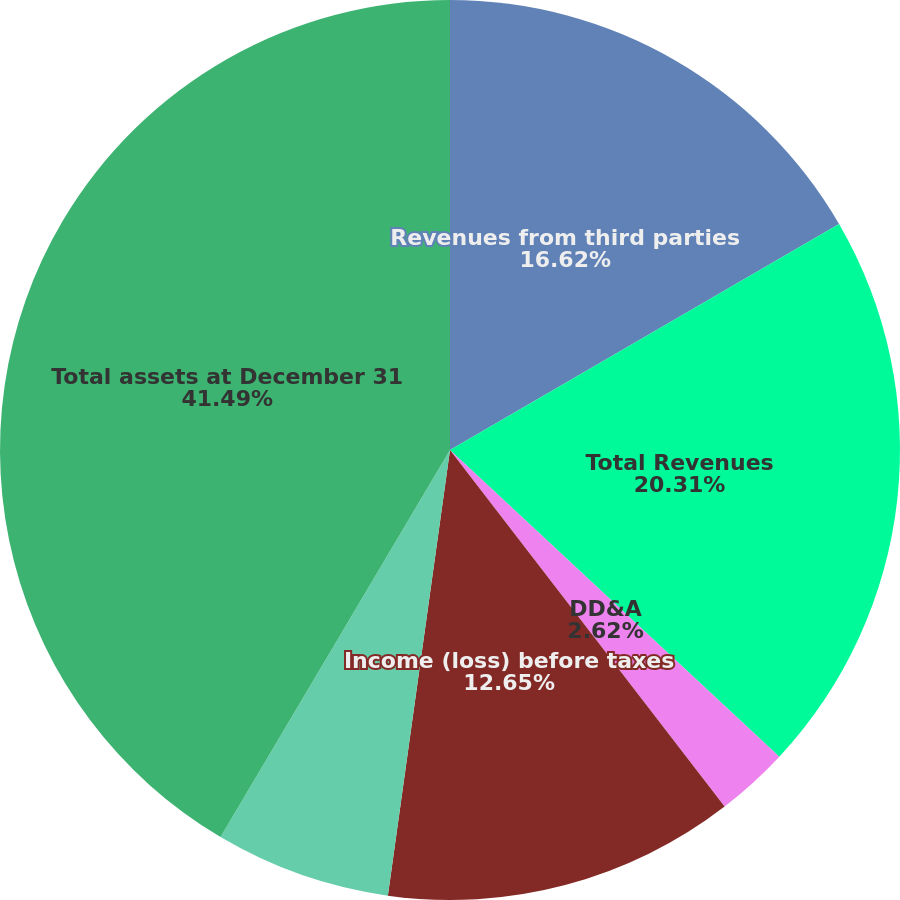<chart> <loc_0><loc_0><loc_500><loc_500><pie_chart><fcel>Revenues from third parties<fcel>Total Revenues<fcel>DD&A<fcel>Income (loss) before taxes<fcel>Additions to long-lived assets<fcel>Total assets at December 31<nl><fcel>16.62%<fcel>20.31%<fcel>2.62%<fcel>12.65%<fcel>6.31%<fcel>41.48%<nl></chart> 